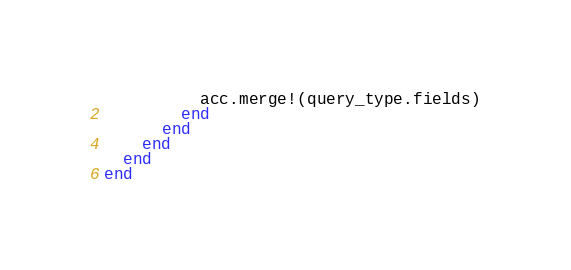<code> <loc_0><loc_0><loc_500><loc_500><_Ruby_>          acc.merge!(query_type.fields)
        end
      end
    end
  end
end
</code> 